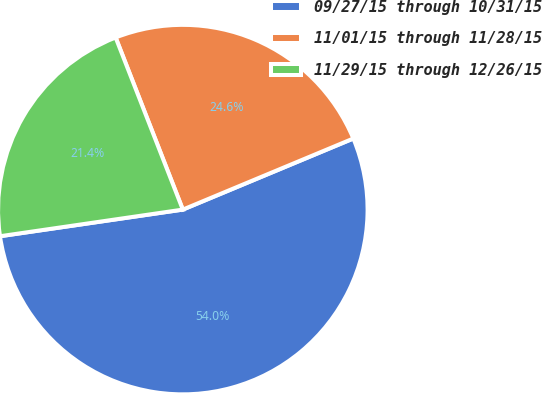Convert chart to OTSL. <chart><loc_0><loc_0><loc_500><loc_500><pie_chart><fcel>09/27/15 through 10/31/15<fcel>11/01/15 through 11/28/15<fcel>11/29/15 through 12/26/15<nl><fcel>53.99%<fcel>24.64%<fcel>21.38%<nl></chart> 